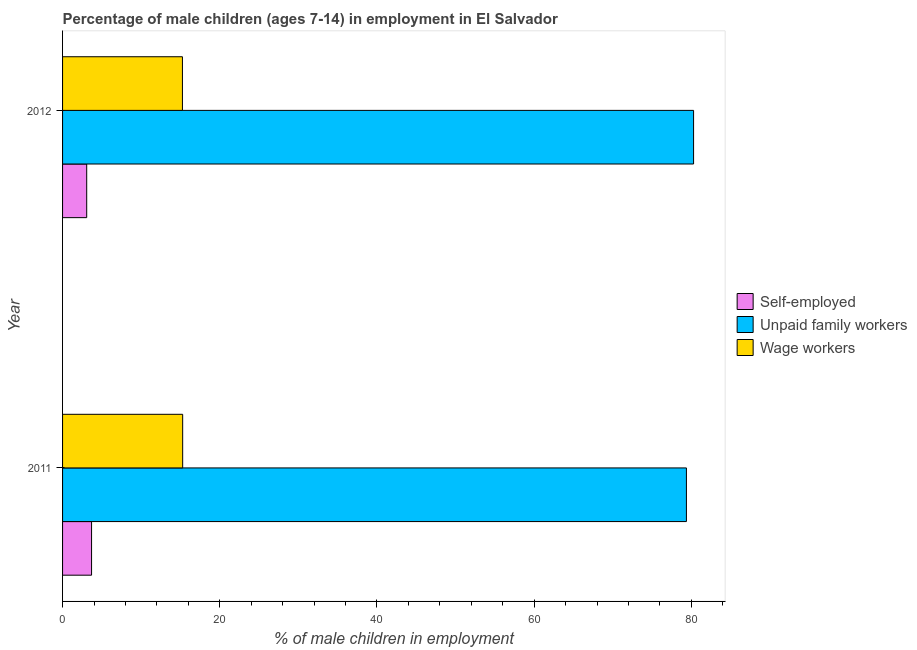Are the number of bars per tick equal to the number of legend labels?
Offer a terse response. Yes. How many bars are there on the 1st tick from the bottom?
Your answer should be compact. 3. In how many cases, is the number of bars for a given year not equal to the number of legend labels?
Offer a terse response. 0. What is the percentage of children employed as unpaid family workers in 2011?
Keep it short and to the point. 79.37. Across all years, what is the maximum percentage of children employed as unpaid family workers?
Keep it short and to the point. 80.28. Across all years, what is the minimum percentage of children employed as wage workers?
Your response must be concise. 15.25. What is the total percentage of self employed children in the graph?
Your response must be concise. 6.76. What is the difference between the percentage of children employed as wage workers in 2011 and that in 2012?
Give a very brief answer. 0.03. What is the difference between the percentage of self employed children in 2011 and the percentage of children employed as unpaid family workers in 2012?
Your response must be concise. -76.59. What is the average percentage of children employed as unpaid family workers per year?
Your answer should be very brief. 79.83. In the year 2012, what is the difference between the percentage of children employed as unpaid family workers and percentage of self employed children?
Your answer should be very brief. 77.21. In how many years, is the percentage of children employed as wage workers greater than 24 %?
Keep it short and to the point. 0. What is the ratio of the percentage of children employed as wage workers in 2011 to that in 2012?
Provide a succinct answer. 1. Is the difference between the percentage of self employed children in 2011 and 2012 greater than the difference between the percentage of children employed as unpaid family workers in 2011 and 2012?
Make the answer very short. Yes. What does the 3rd bar from the top in 2011 represents?
Give a very brief answer. Self-employed. What does the 1st bar from the bottom in 2011 represents?
Offer a terse response. Self-employed. How many bars are there?
Offer a terse response. 6. How many years are there in the graph?
Ensure brevity in your answer.  2. Does the graph contain grids?
Offer a terse response. No. Where does the legend appear in the graph?
Make the answer very short. Center right. How many legend labels are there?
Make the answer very short. 3. How are the legend labels stacked?
Ensure brevity in your answer.  Vertical. What is the title of the graph?
Your answer should be very brief. Percentage of male children (ages 7-14) in employment in El Salvador. Does "Ages 65 and above" appear as one of the legend labels in the graph?
Offer a terse response. No. What is the label or title of the X-axis?
Your response must be concise. % of male children in employment. What is the % of male children in employment of Self-employed in 2011?
Your response must be concise. 3.69. What is the % of male children in employment of Unpaid family workers in 2011?
Keep it short and to the point. 79.37. What is the % of male children in employment in Wage workers in 2011?
Offer a very short reply. 15.28. What is the % of male children in employment in Self-employed in 2012?
Give a very brief answer. 3.07. What is the % of male children in employment in Unpaid family workers in 2012?
Your answer should be very brief. 80.28. What is the % of male children in employment in Wage workers in 2012?
Provide a succinct answer. 15.25. Across all years, what is the maximum % of male children in employment of Self-employed?
Provide a succinct answer. 3.69. Across all years, what is the maximum % of male children in employment in Unpaid family workers?
Your answer should be compact. 80.28. Across all years, what is the maximum % of male children in employment in Wage workers?
Your response must be concise. 15.28. Across all years, what is the minimum % of male children in employment of Self-employed?
Keep it short and to the point. 3.07. Across all years, what is the minimum % of male children in employment in Unpaid family workers?
Your answer should be compact. 79.37. Across all years, what is the minimum % of male children in employment in Wage workers?
Provide a short and direct response. 15.25. What is the total % of male children in employment of Self-employed in the graph?
Make the answer very short. 6.76. What is the total % of male children in employment of Unpaid family workers in the graph?
Keep it short and to the point. 159.65. What is the total % of male children in employment of Wage workers in the graph?
Your answer should be compact. 30.53. What is the difference between the % of male children in employment in Self-employed in 2011 and that in 2012?
Provide a succinct answer. 0.62. What is the difference between the % of male children in employment of Unpaid family workers in 2011 and that in 2012?
Provide a short and direct response. -0.91. What is the difference between the % of male children in employment in Wage workers in 2011 and that in 2012?
Offer a terse response. 0.03. What is the difference between the % of male children in employment in Self-employed in 2011 and the % of male children in employment in Unpaid family workers in 2012?
Offer a terse response. -76.59. What is the difference between the % of male children in employment in Self-employed in 2011 and the % of male children in employment in Wage workers in 2012?
Make the answer very short. -11.56. What is the difference between the % of male children in employment in Unpaid family workers in 2011 and the % of male children in employment in Wage workers in 2012?
Provide a short and direct response. 64.12. What is the average % of male children in employment of Self-employed per year?
Keep it short and to the point. 3.38. What is the average % of male children in employment in Unpaid family workers per year?
Offer a terse response. 79.83. What is the average % of male children in employment in Wage workers per year?
Offer a terse response. 15.27. In the year 2011, what is the difference between the % of male children in employment of Self-employed and % of male children in employment of Unpaid family workers?
Make the answer very short. -75.68. In the year 2011, what is the difference between the % of male children in employment of Self-employed and % of male children in employment of Wage workers?
Your answer should be very brief. -11.59. In the year 2011, what is the difference between the % of male children in employment of Unpaid family workers and % of male children in employment of Wage workers?
Provide a short and direct response. 64.09. In the year 2012, what is the difference between the % of male children in employment of Self-employed and % of male children in employment of Unpaid family workers?
Offer a terse response. -77.21. In the year 2012, what is the difference between the % of male children in employment of Self-employed and % of male children in employment of Wage workers?
Ensure brevity in your answer.  -12.18. In the year 2012, what is the difference between the % of male children in employment of Unpaid family workers and % of male children in employment of Wage workers?
Ensure brevity in your answer.  65.03. What is the ratio of the % of male children in employment in Self-employed in 2011 to that in 2012?
Your answer should be very brief. 1.2. What is the ratio of the % of male children in employment in Unpaid family workers in 2011 to that in 2012?
Ensure brevity in your answer.  0.99. What is the difference between the highest and the second highest % of male children in employment in Self-employed?
Offer a terse response. 0.62. What is the difference between the highest and the second highest % of male children in employment of Unpaid family workers?
Your response must be concise. 0.91. What is the difference between the highest and the second highest % of male children in employment in Wage workers?
Ensure brevity in your answer.  0.03. What is the difference between the highest and the lowest % of male children in employment of Self-employed?
Provide a short and direct response. 0.62. What is the difference between the highest and the lowest % of male children in employment in Unpaid family workers?
Provide a succinct answer. 0.91. What is the difference between the highest and the lowest % of male children in employment in Wage workers?
Provide a short and direct response. 0.03. 